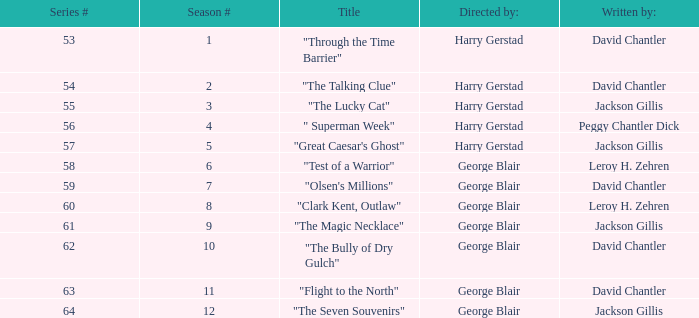Which Season originally aired on September 17, 1955 9.0. 